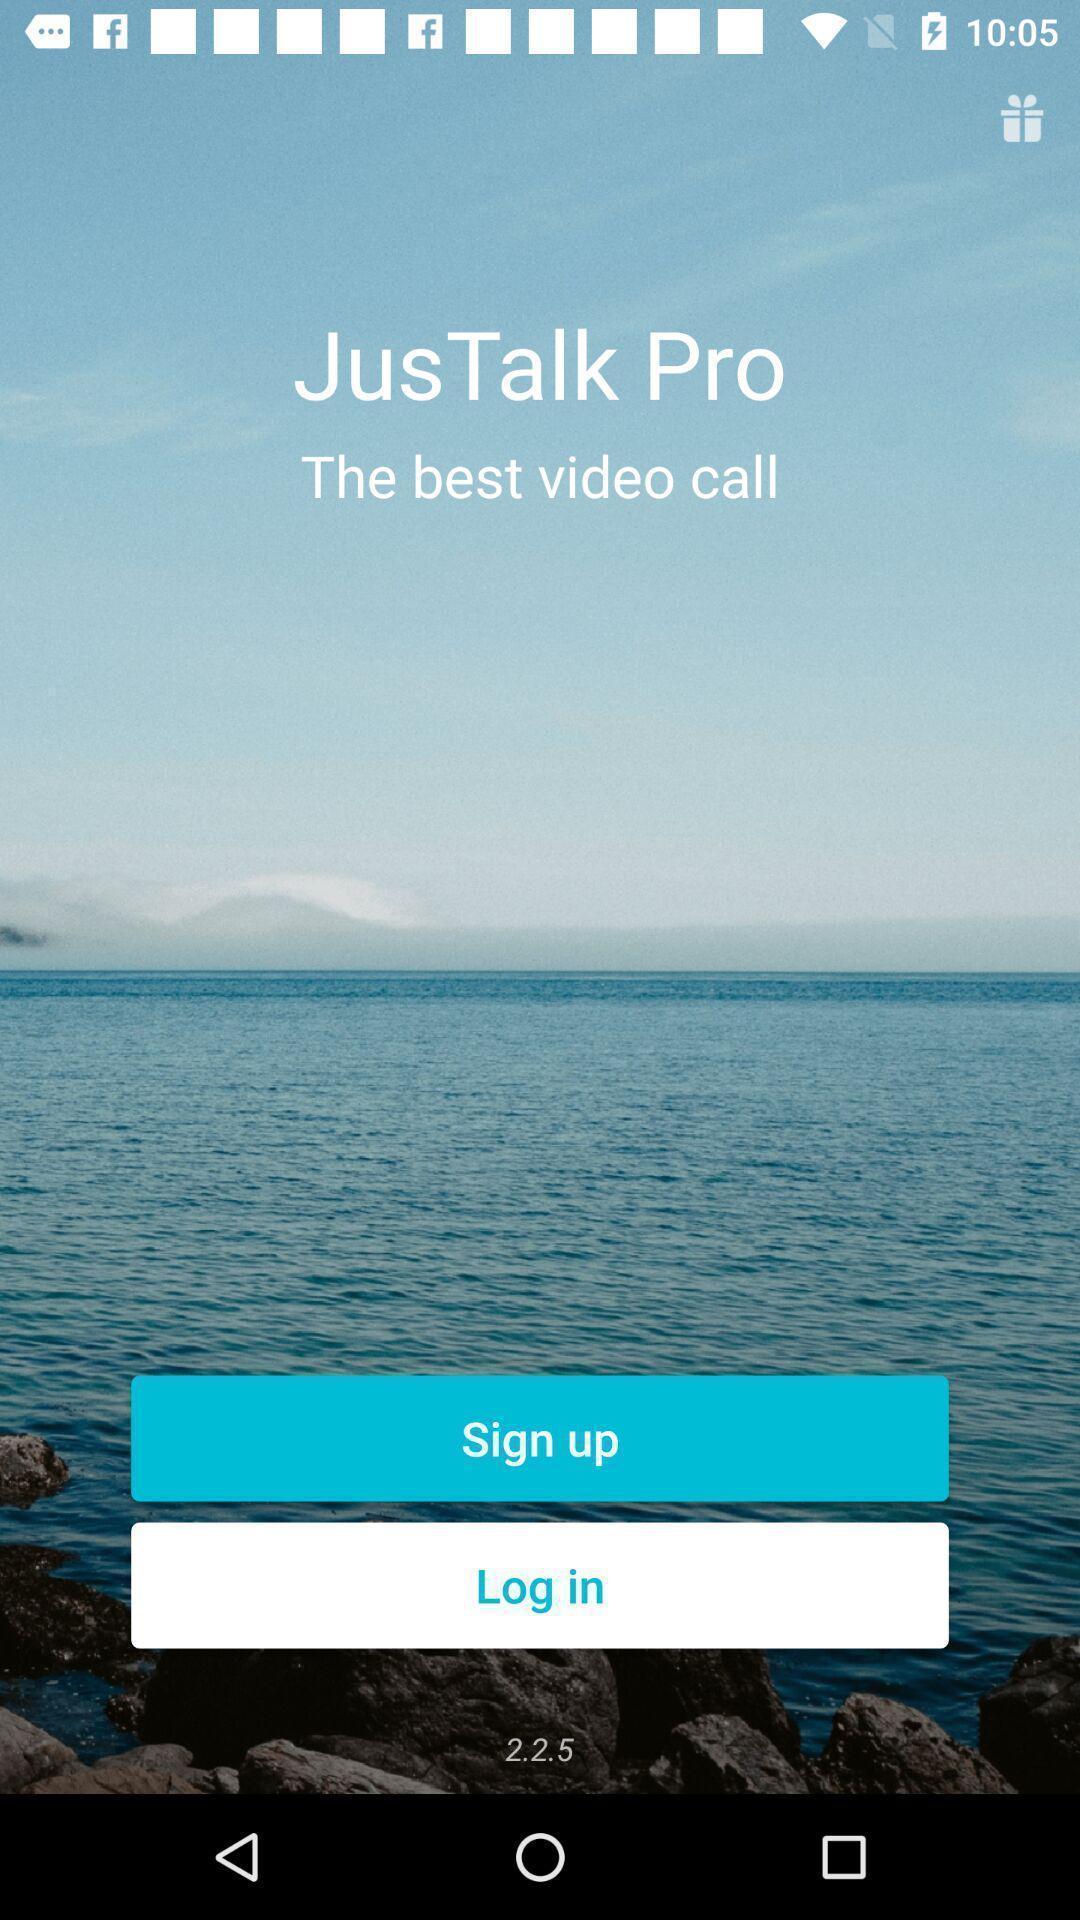Please provide a description for this image. Welcome page of a video calling app. 